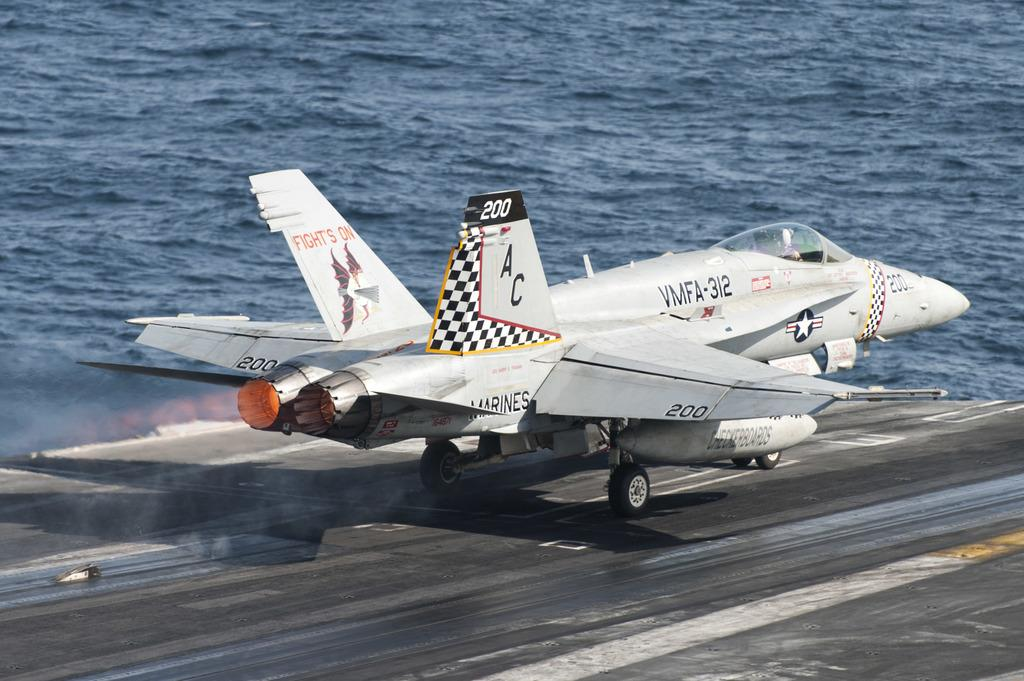<image>
Describe the image concisely. A jet is shown on an aircraft carrier and has the identifier VMFA-312 on it. 